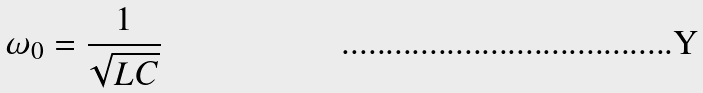<formula> <loc_0><loc_0><loc_500><loc_500>\omega _ { 0 } = \frac { 1 } { \sqrt { L C } }</formula> 